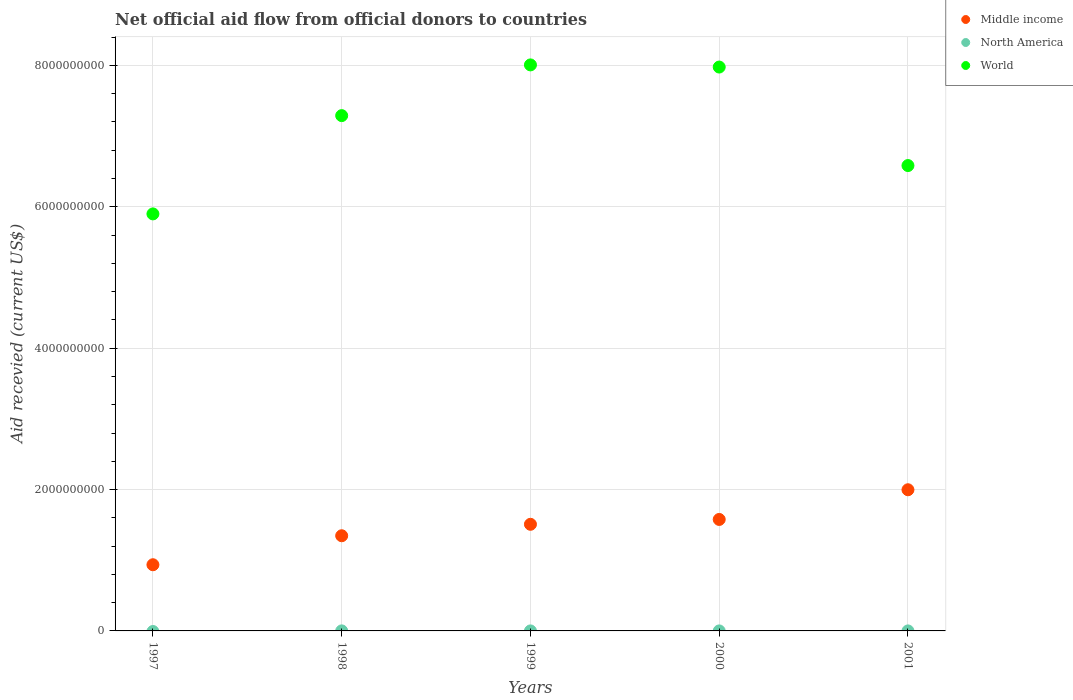Across all years, what is the maximum total aid received in North America?
Provide a short and direct response. 5.50e+05. Across all years, what is the minimum total aid received in Middle income?
Your answer should be very brief. 9.36e+08. In which year was the total aid received in Middle income maximum?
Offer a very short reply. 2001. What is the total total aid received in Middle income in the graph?
Offer a terse response. 7.37e+09. What is the difference between the total aid received in World in 1997 and that in 1999?
Provide a short and direct response. -2.11e+09. What is the difference between the total aid received in North America in 1998 and the total aid received in Middle income in 1997?
Offer a very short reply. -9.36e+08. What is the average total aid received in World per year?
Offer a terse response. 7.15e+09. In the year 1998, what is the difference between the total aid received in World and total aid received in Middle income?
Your answer should be very brief. 5.94e+09. In how many years, is the total aid received in Middle income greater than 7600000000 US$?
Ensure brevity in your answer.  0. What is the ratio of the total aid received in Middle income in 1997 to that in 1998?
Provide a short and direct response. 0.7. Is the total aid received in Middle income in 1998 less than that in 2001?
Your response must be concise. Yes. Is the difference between the total aid received in World in 1999 and 2001 greater than the difference between the total aid received in Middle income in 1999 and 2001?
Make the answer very short. Yes. What is the difference between the highest and the second highest total aid received in Middle income?
Offer a terse response. 4.20e+08. In how many years, is the total aid received in North America greater than the average total aid received in North America taken over all years?
Keep it short and to the point. 1. Is it the case that in every year, the sum of the total aid received in North America and total aid received in World  is greater than the total aid received in Middle income?
Keep it short and to the point. Yes. Does the total aid received in North America monotonically increase over the years?
Your answer should be very brief. No. What is the difference between two consecutive major ticks on the Y-axis?
Provide a succinct answer. 2.00e+09. Does the graph contain any zero values?
Make the answer very short. Yes. Does the graph contain grids?
Give a very brief answer. Yes. Where does the legend appear in the graph?
Your answer should be very brief. Top right. How many legend labels are there?
Give a very brief answer. 3. What is the title of the graph?
Ensure brevity in your answer.  Net official aid flow from official donors to countries. Does "Marshall Islands" appear as one of the legend labels in the graph?
Provide a succinct answer. No. What is the label or title of the Y-axis?
Provide a short and direct response. Aid recevied (current US$). What is the Aid recevied (current US$) in Middle income in 1997?
Offer a terse response. 9.36e+08. What is the Aid recevied (current US$) in North America in 1997?
Keep it short and to the point. 0. What is the Aid recevied (current US$) in World in 1997?
Your answer should be very brief. 5.90e+09. What is the Aid recevied (current US$) in Middle income in 1998?
Provide a succinct answer. 1.35e+09. What is the Aid recevied (current US$) of North America in 1998?
Offer a very short reply. 5.50e+05. What is the Aid recevied (current US$) in World in 1998?
Offer a terse response. 7.29e+09. What is the Aid recevied (current US$) in Middle income in 1999?
Your response must be concise. 1.51e+09. What is the Aid recevied (current US$) in World in 1999?
Ensure brevity in your answer.  8.01e+09. What is the Aid recevied (current US$) in Middle income in 2000?
Provide a short and direct response. 1.58e+09. What is the Aid recevied (current US$) in World in 2000?
Your answer should be compact. 7.98e+09. What is the Aid recevied (current US$) of Middle income in 2001?
Offer a very short reply. 2.00e+09. What is the Aid recevied (current US$) in World in 2001?
Your response must be concise. 6.58e+09. Across all years, what is the maximum Aid recevied (current US$) of Middle income?
Offer a very short reply. 2.00e+09. Across all years, what is the maximum Aid recevied (current US$) in World?
Keep it short and to the point. 8.01e+09. Across all years, what is the minimum Aid recevied (current US$) of Middle income?
Ensure brevity in your answer.  9.36e+08. Across all years, what is the minimum Aid recevied (current US$) in North America?
Your answer should be very brief. 0. Across all years, what is the minimum Aid recevied (current US$) in World?
Offer a very short reply. 5.90e+09. What is the total Aid recevied (current US$) in Middle income in the graph?
Give a very brief answer. 7.37e+09. What is the total Aid recevied (current US$) in North America in the graph?
Provide a short and direct response. 7.10e+05. What is the total Aid recevied (current US$) of World in the graph?
Keep it short and to the point. 3.58e+1. What is the difference between the Aid recevied (current US$) of Middle income in 1997 and that in 1998?
Make the answer very short. -4.10e+08. What is the difference between the Aid recevied (current US$) of World in 1997 and that in 1998?
Ensure brevity in your answer.  -1.39e+09. What is the difference between the Aid recevied (current US$) in Middle income in 1997 and that in 1999?
Make the answer very short. -5.72e+08. What is the difference between the Aid recevied (current US$) of World in 1997 and that in 1999?
Make the answer very short. -2.11e+09. What is the difference between the Aid recevied (current US$) in Middle income in 1997 and that in 2000?
Give a very brief answer. -6.41e+08. What is the difference between the Aid recevied (current US$) in World in 1997 and that in 2000?
Give a very brief answer. -2.08e+09. What is the difference between the Aid recevied (current US$) in Middle income in 1997 and that in 2001?
Provide a short and direct response. -1.06e+09. What is the difference between the Aid recevied (current US$) of World in 1997 and that in 2001?
Ensure brevity in your answer.  -6.84e+08. What is the difference between the Aid recevied (current US$) in Middle income in 1998 and that in 1999?
Provide a short and direct response. -1.62e+08. What is the difference between the Aid recevied (current US$) in North America in 1998 and that in 1999?
Keep it short and to the point. 4.70e+05. What is the difference between the Aid recevied (current US$) of World in 1998 and that in 1999?
Keep it short and to the point. -7.18e+08. What is the difference between the Aid recevied (current US$) in Middle income in 1998 and that in 2000?
Provide a short and direct response. -2.31e+08. What is the difference between the Aid recevied (current US$) in North America in 1998 and that in 2000?
Offer a very short reply. 4.90e+05. What is the difference between the Aid recevied (current US$) of World in 1998 and that in 2000?
Your answer should be very brief. -6.87e+08. What is the difference between the Aid recevied (current US$) of Middle income in 1998 and that in 2001?
Give a very brief answer. -6.51e+08. What is the difference between the Aid recevied (current US$) in North America in 1998 and that in 2001?
Provide a short and direct response. 5.30e+05. What is the difference between the Aid recevied (current US$) of World in 1998 and that in 2001?
Give a very brief answer. 7.06e+08. What is the difference between the Aid recevied (current US$) of Middle income in 1999 and that in 2000?
Your answer should be very brief. -6.85e+07. What is the difference between the Aid recevied (current US$) of North America in 1999 and that in 2000?
Offer a very short reply. 2.00e+04. What is the difference between the Aid recevied (current US$) in World in 1999 and that in 2000?
Offer a very short reply. 3.04e+07. What is the difference between the Aid recevied (current US$) of Middle income in 1999 and that in 2001?
Offer a terse response. -4.89e+08. What is the difference between the Aid recevied (current US$) of World in 1999 and that in 2001?
Your response must be concise. 1.42e+09. What is the difference between the Aid recevied (current US$) in Middle income in 2000 and that in 2001?
Keep it short and to the point. -4.20e+08. What is the difference between the Aid recevied (current US$) in North America in 2000 and that in 2001?
Your answer should be very brief. 4.00e+04. What is the difference between the Aid recevied (current US$) of World in 2000 and that in 2001?
Offer a terse response. 1.39e+09. What is the difference between the Aid recevied (current US$) in Middle income in 1997 and the Aid recevied (current US$) in North America in 1998?
Offer a terse response. 9.36e+08. What is the difference between the Aid recevied (current US$) in Middle income in 1997 and the Aid recevied (current US$) in World in 1998?
Make the answer very short. -6.35e+09. What is the difference between the Aid recevied (current US$) of Middle income in 1997 and the Aid recevied (current US$) of North America in 1999?
Provide a succinct answer. 9.36e+08. What is the difference between the Aid recevied (current US$) in Middle income in 1997 and the Aid recevied (current US$) in World in 1999?
Your response must be concise. -7.07e+09. What is the difference between the Aid recevied (current US$) of Middle income in 1997 and the Aid recevied (current US$) of North America in 2000?
Give a very brief answer. 9.36e+08. What is the difference between the Aid recevied (current US$) of Middle income in 1997 and the Aid recevied (current US$) of World in 2000?
Your answer should be very brief. -7.04e+09. What is the difference between the Aid recevied (current US$) in Middle income in 1997 and the Aid recevied (current US$) in North America in 2001?
Your answer should be very brief. 9.36e+08. What is the difference between the Aid recevied (current US$) in Middle income in 1997 and the Aid recevied (current US$) in World in 2001?
Provide a succinct answer. -5.65e+09. What is the difference between the Aid recevied (current US$) of Middle income in 1998 and the Aid recevied (current US$) of North America in 1999?
Make the answer very short. 1.35e+09. What is the difference between the Aid recevied (current US$) of Middle income in 1998 and the Aid recevied (current US$) of World in 1999?
Your response must be concise. -6.66e+09. What is the difference between the Aid recevied (current US$) of North America in 1998 and the Aid recevied (current US$) of World in 1999?
Make the answer very short. -8.01e+09. What is the difference between the Aid recevied (current US$) in Middle income in 1998 and the Aid recevied (current US$) in North America in 2000?
Offer a very short reply. 1.35e+09. What is the difference between the Aid recevied (current US$) of Middle income in 1998 and the Aid recevied (current US$) of World in 2000?
Your answer should be compact. -6.63e+09. What is the difference between the Aid recevied (current US$) in North America in 1998 and the Aid recevied (current US$) in World in 2000?
Make the answer very short. -7.98e+09. What is the difference between the Aid recevied (current US$) of Middle income in 1998 and the Aid recevied (current US$) of North America in 2001?
Offer a terse response. 1.35e+09. What is the difference between the Aid recevied (current US$) of Middle income in 1998 and the Aid recevied (current US$) of World in 2001?
Give a very brief answer. -5.24e+09. What is the difference between the Aid recevied (current US$) of North America in 1998 and the Aid recevied (current US$) of World in 2001?
Your response must be concise. -6.58e+09. What is the difference between the Aid recevied (current US$) in Middle income in 1999 and the Aid recevied (current US$) in North America in 2000?
Keep it short and to the point. 1.51e+09. What is the difference between the Aid recevied (current US$) in Middle income in 1999 and the Aid recevied (current US$) in World in 2000?
Your response must be concise. -6.47e+09. What is the difference between the Aid recevied (current US$) in North America in 1999 and the Aid recevied (current US$) in World in 2000?
Provide a succinct answer. -7.98e+09. What is the difference between the Aid recevied (current US$) in Middle income in 1999 and the Aid recevied (current US$) in North America in 2001?
Ensure brevity in your answer.  1.51e+09. What is the difference between the Aid recevied (current US$) in Middle income in 1999 and the Aid recevied (current US$) in World in 2001?
Your answer should be very brief. -5.08e+09. What is the difference between the Aid recevied (current US$) in North America in 1999 and the Aid recevied (current US$) in World in 2001?
Keep it short and to the point. -6.58e+09. What is the difference between the Aid recevied (current US$) of Middle income in 2000 and the Aid recevied (current US$) of North America in 2001?
Make the answer very short. 1.58e+09. What is the difference between the Aid recevied (current US$) of Middle income in 2000 and the Aid recevied (current US$) of World in 2001?
Your answer should be compact. -5.01e+09. What is the difference between the Aid recevied (current US$) in North America in 2000 and the Aid recevied (current US$) in World in 2001?
Your answer should be compact. -6.58e+09. What is the average Aid recevied (current US$) in Middle income per year?
Offer a very short reply. 1.47e+09. What is the average Aid recevied (current US$) of North America per year?
Offer a terse response. 1.42e+05. What is the average Aid recevied (current US$) in World per year?
Provide a short and direct response. 7.15e+09. In the year 1997, what is the difference between the Aid recevied (current US$) in Middle income and Aid recevied (current US$) in World?
Your answer should be very brief. -4.96e+09. In the year 1998, what is the difference between the Aid recevied (current US$) in Middle income and Aid recevied (current US$) in North America?
Offer a terse response. 1.35e+09. In the year 1998, what is the difference between the Aid recevied (current US$) in Middle income and Aid recevied (current US$) in World?
Ensure brevity in your answer.  -5.94e+09. In the year 1998, what is the difference between the Aid recevied (current US$) in North America and Aid recevied (current US$) in World?
Provide a short and direct response. -7.29e+09. In the year 1999, what is the difference between the Aid recevied (current US$) in Middle income and Aid recevied (current US$) in North America?
Your response must be concise. 1.51e+09. In the year 1999, what is the difference between the Aid recevied (current US$) in Middle income and Aid recevied (current US$) in World?
Your response must be concise. -6.50e+09. In the year 1999, what is the difference between the Aid recevied (current US$) of North America and Aid recevied (current US$) of World?
Your answer should be very brief. -8.01e+09. In the year 2000, what is the difference between the Aid recevied (current US$) in Middle income and Aid recevied (current US$) in North America?
Your answer should be very brief. 1.58e+09. In the year 2000, what is the difference between the Aid recevied (current US$) of Middle income and Aid recevied (current US$) of World?
Offer a terse response. -6.40e+09. In the year 2000, what is the difference between the Aid recevied (current US$) of North America and Aid recevied (current US$) of World?
Offer a very short reply. -7.98e+09. In the year 2001, what is the difference between the Aid recevied (current US$) in Middle income and Aid recevied (current US$) in North America?
Provide a short and direct response. 2.00e+09. In the year 2001, what is the difference between the Aid recevied (current US$) of Middle income and Aid recevied (current US$) of World?
Your response must be concise. -4.59e+09. In the year 2001, what is the difference between the Aid recevied (current US$) in North America and Aid recevied (current US$) in World?
Your answer should be very brief. -6.58e+09. What is the ratio of the Aid recevied (current US$) of Middle income in 1997 to that in 1998?
Offer a terse response. 0.7. What is the ratio of the Aid recevied (current US$) of World in 1997 to that in 1998?
Offer a terse response. 0.81. What is the ratio of the Aid recevied (current US$) in Middle income in 1997 to that in 1999?
Offer a terse response. 0.62. What is the ratio of the Aid recevied (current US$) of World in 1997 to that in 1999?
Your answer should be compact. 0.74. What is the ratio of the Aid recevied (current US$) of Middle income in 1997 to that in 2000?
Provide a succinct answer. 0.59. What is the ratio of the Aid recevied (current US$) in World in 1997 to that in 2000?
Offer a very short reply. 0.74. What is the ratio of the Aid recevied (current US$) of Middle income in 1997 to that in 2001?
Your response must be concise. 0.47. What is the ratio of the Aid recevied (current US$) in World in 1997 to that in 2001?
Offer a very short reply. 0.9. What is the ratio of the Aid recevied (current US$) in Middle income in 1998 to that in 1999?
Keep it short and to the point. 0.89. What is the ratio of the Aid recevied (current US$) of North America in 1998 to that in 1999?
Give a very brief answer. 6.88. What is the ratio of the Aid recevied (current US$) in World in 1998 to that in 1999?
Ensure brevity in your answer.  0.91. What is the ratio of the Aid recevied (current US$) of Middle income in 1998 to that in 2000?
Make the answer very short. 0.85. What is the ratio of the Aid recevied (current US$) in North America in 1998 to that in 2000?
Offer a terse response. 9.17. What is the ratio of the Aid recevied (current US$) of World in 1998 to that in 2000?
Provide a short and direct response. 0.91. What is the ratio of the Aid recevied (current US$) in Middle income in 1998 to that in 2001?
Offer a terse response. 0.67. What is the ratio of the Aid recevied (current US$) of World in 1998 to that in 2001?
Offer a terse response. 1.11. What is the ratio of the Aid recevied (current US$) in Middle income in 1999 to that in 2000?
Provide a succinct answer. 0.96. What is the ratio of the Aid recevied (current US$) of North America in 1999 to that in 2000?
Offer a very short reply. 1.33. What is the ratio of the Aid recevied (current US$) in Middle income in 1999 to that in 2001?
Provide a short and direct response. 0.76. What is the ratio of the Aid recevied (current US$) of World in 1999 to that in 2001?
Your answer should be compact. 1.22. What is the ratio of the Aid recevied (current US$) in Middle income in 2000 to that in 2001?
Ensure brevity in your answer.  0.79. What is the ratio of the Aid recevied (current US$) in World in 2000 to that in 2001?
Provide a short and direct response. 1.21. What is the difference between the highest and the second highest Aid recevied (current US$) in Middle income?
Your answer should be very brief. 4.20e+08. What is the difference between the highest and the second highest Aid recevied (current US$) in World?
Ensure brevity in your answer.  3.04e+07. What is the difference between the highest and the lowest Aid recevied (current US$) of Middle income?
Make the answer very short. 1.06e+09. What is the difference between the highest and the lowest Aid recevied (current US$) of North America?
Provide a short and direct response. 5.50e+05. What is the difference between the highest and the lowest Aid recevied (current US$) of World?
Offer a very short reply. 2.11e+09. 